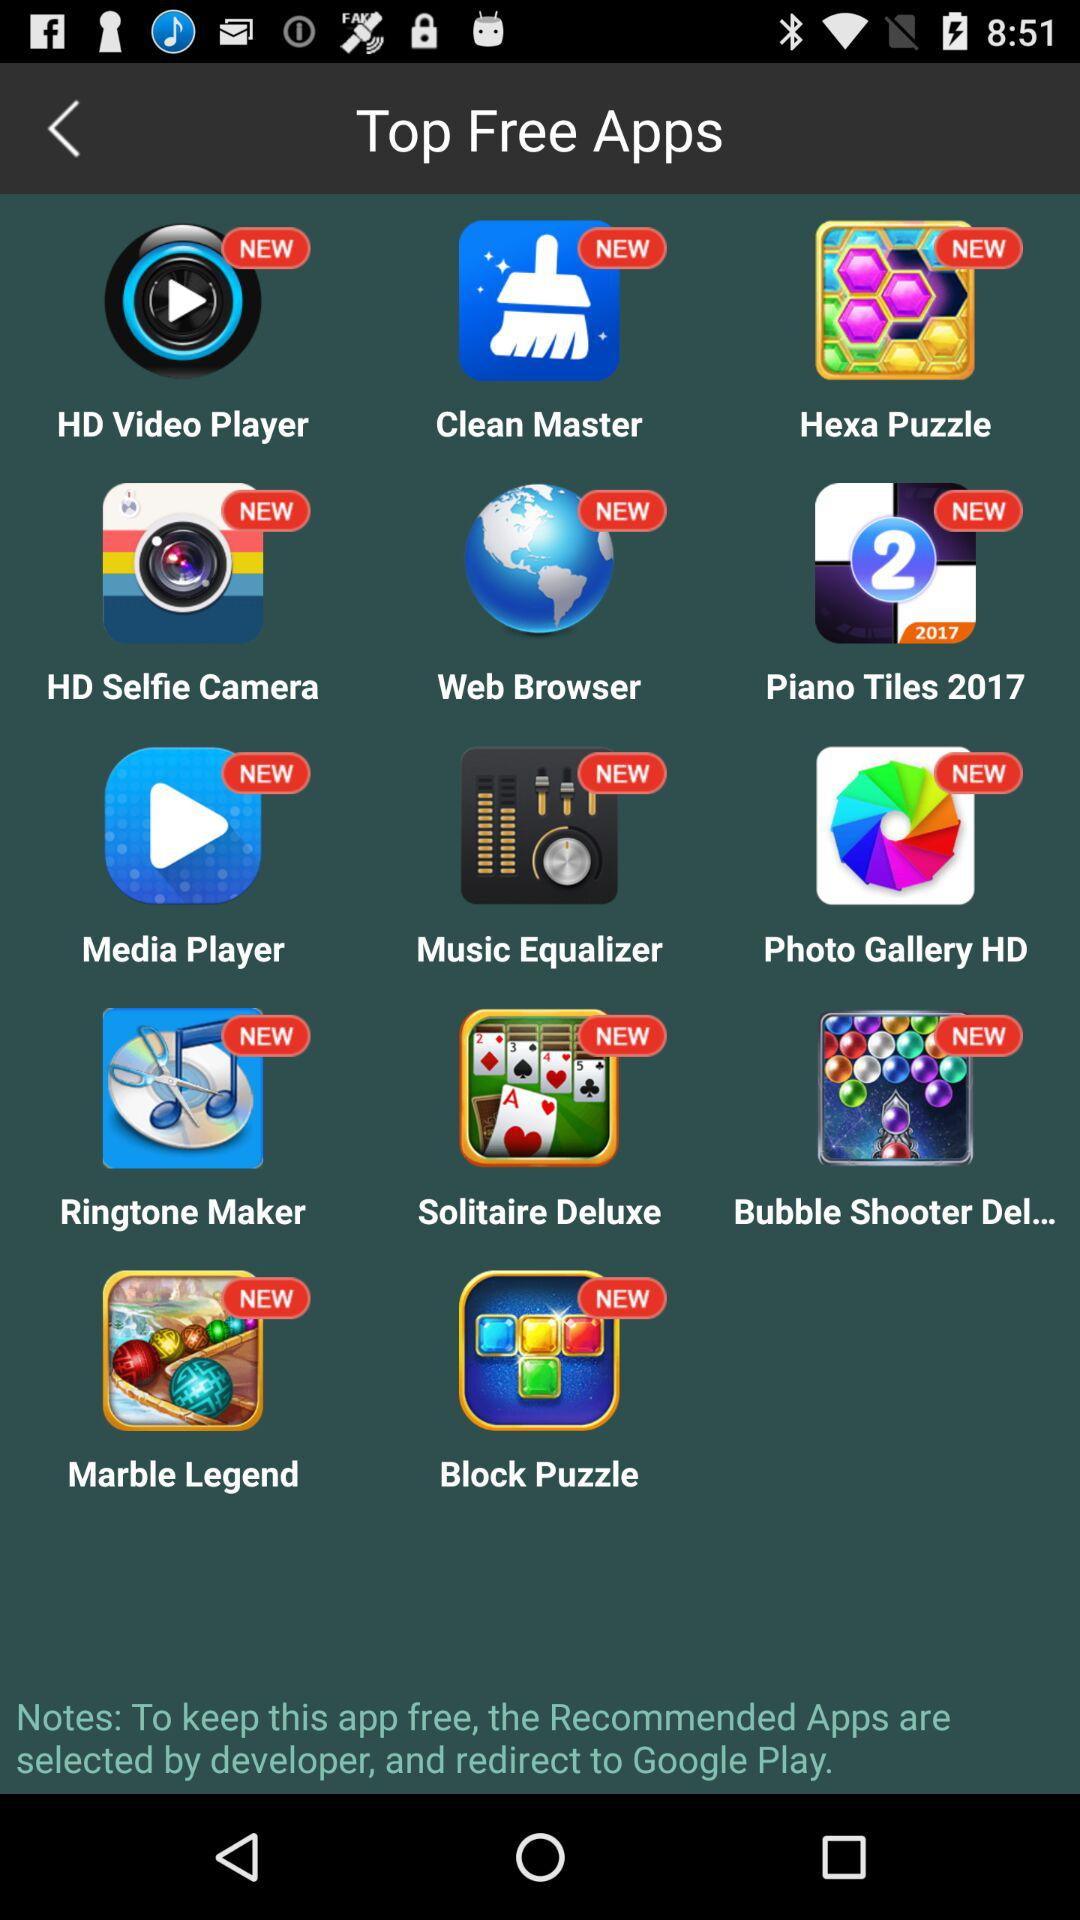What are the different top free apps that are available? The different top free apps are "HD Video Player", "Clean Master", "Hexa Puzzle", "HD Selfie Camera", "Web Browser", "Piano Tiles 2017", "Media Player", "Music Equalizer", "Photo Gallery HD", "Ringtone Maker", "Solitaire Deluxe", "Bubble Shooter Del...", "Marble Legend" and "Block Puzzle". 